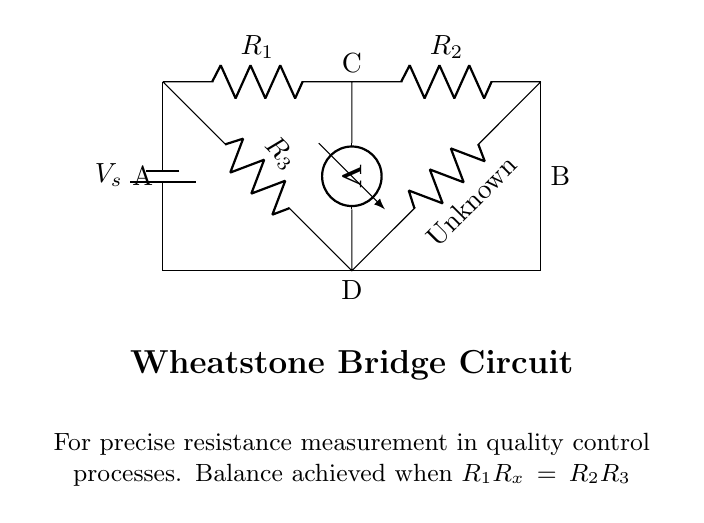What are the components labeled in this circuit? The circuit contains four resistors (R1, R2, R3, Rx) and a battery (Vs). The resistors are connected in a specific configuration and the battery provides the necessary voltage.
Answer: Four resistors and one battery What happens at point C when the bridge is balanced? When the bridge is balanced, the voltmeter reads zero, meaning that the ratio of the resistances is equal (R1/R2 = R3/Rx), indicating there is no voltage difference across the midpoints.
Answer: Zero volts How is the unknown resistance denoted in this circuit? The unknown resistance in the Wheatstone bridge is denoted by Rx, which is specifically marked in the diagram for clear identification.
Answer: Rx What condition must be met for balance in the Wheatstone bridge? The condition for balance is that the product of R1 and Rx equals the product of R2 and R3 (R1Rx = R2R3), which ensures precise measurement.
Answer: R1Rx = R2R3 Which component is used to measure voltage in this circuit? The voltmeter is the component used to measure voltage across the midpoints of the bridge circuit, indicating balance or imbalance in the resistance values.
Answer: Voltmeter What does the term 'Wheatstone Bridge' refer to in this context? The term refers to a specific type of electrical circuit configuration used for precise measurement of resistance by comparing unknown and known resistors.
Answer: A precise resistance measurement circuit 